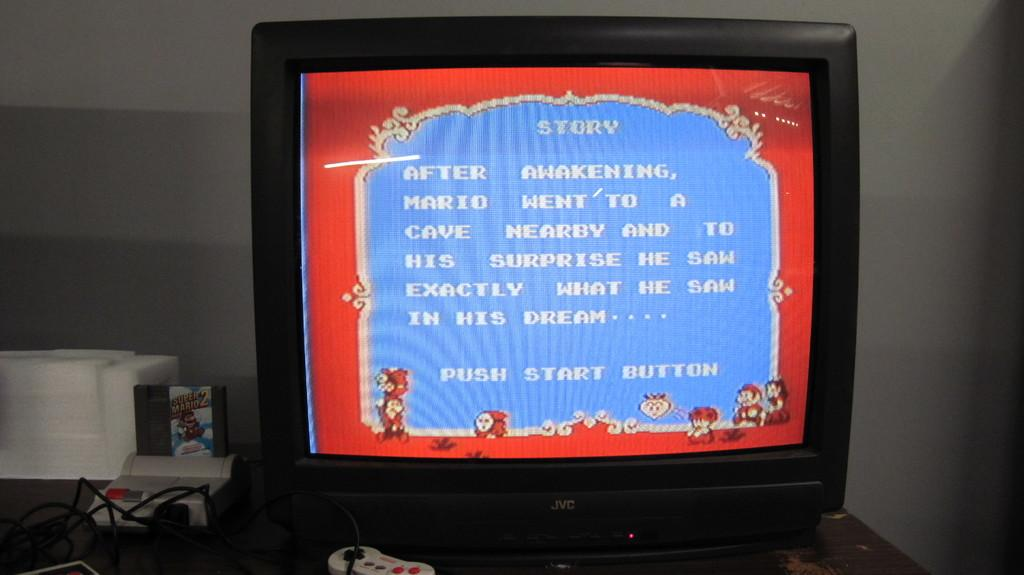<image>
Relay a brief, clear account of the picture shown. A Mario game is being played and the television screen says Push Start Button. 